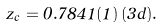<formula> <loc_0><loc_0><loc_500><loc_500>z _ { c } = 0 . 7 8 4 1 ( 1 ) \, ( 3 d ) .</formula> 